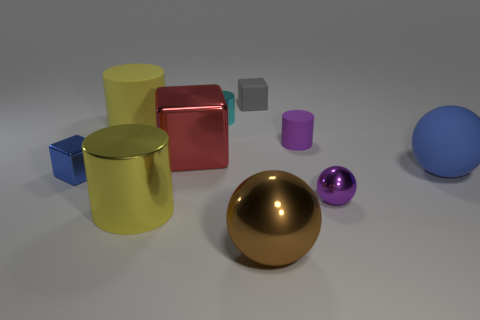Subtract 1 balls. How many balls are left? 2 Subtract all metal blocks. How many blocks are left? 1 Subtract all cyan cylinders. How many cylinders are left? 3 Subtract all green cylinders. Subtract all red spheres. How many cylinders are left? 4 Subtract all cylinders. How many objects are left? 6 Add 4 small blue cubes. How many small blue cubes exist? 5 Subtract 1 gray blocks. How many objects are left? 9 Subtract all large rubber spheres. Subtract all small shiny things. How many objects are left? 6 Add 1 tiny blue things. How many tiny blue things are left? 2 